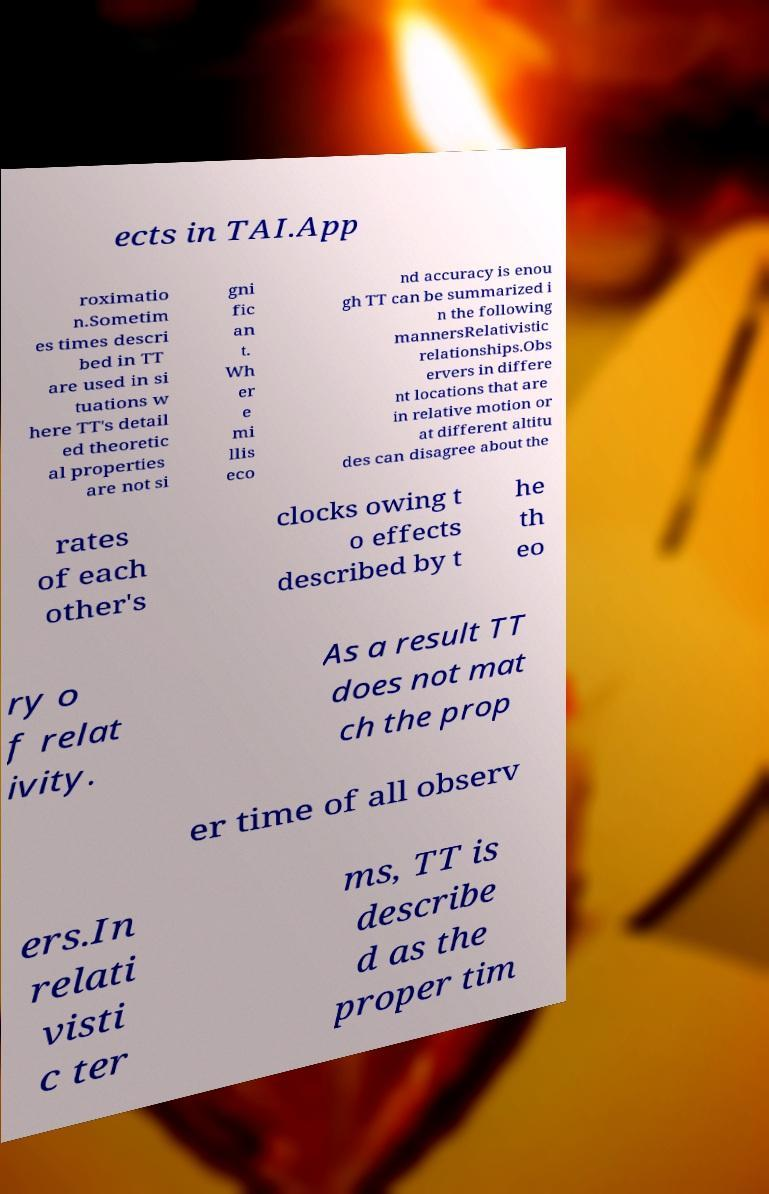Please identify and transcribe the text found in this image. ects in TAI.App roximatio n.Sometim es times descri bed in TT are used in si tuations w here TT's detail ed theoretic al properties are not si gni fic an t. Wh er e mi llis eco nd accuracy is enou gh TT can be summarized i n the following mannersRelativistic relationships.Obs ervers in differe nt locations that are in relative motion or at different altitu des can disagree about the rates of each other's clocks owing t o effects described by t he th eo ry o f relat ivity. As a result TT does not mat ch the prop er time of all observ ers.In relati visti c ter ms, TT is describe d as the proper tim 